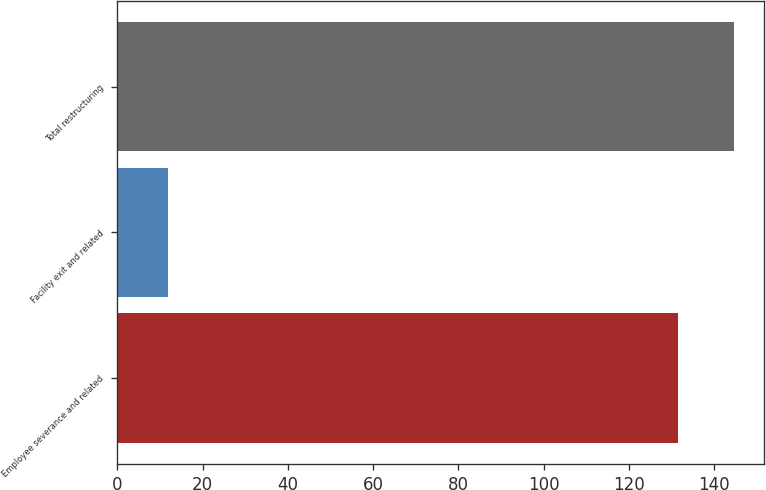Convert chart to OTSL. <chart><loc_0><loc_0><loc_500><loc_500><bar_chart><fcel>Employee severance and related<fcel>Facility exit and related<fcel>Total restructuring<nl><fcel>131.4<fcel>11.8<fcel>144.54<nl></chart> 